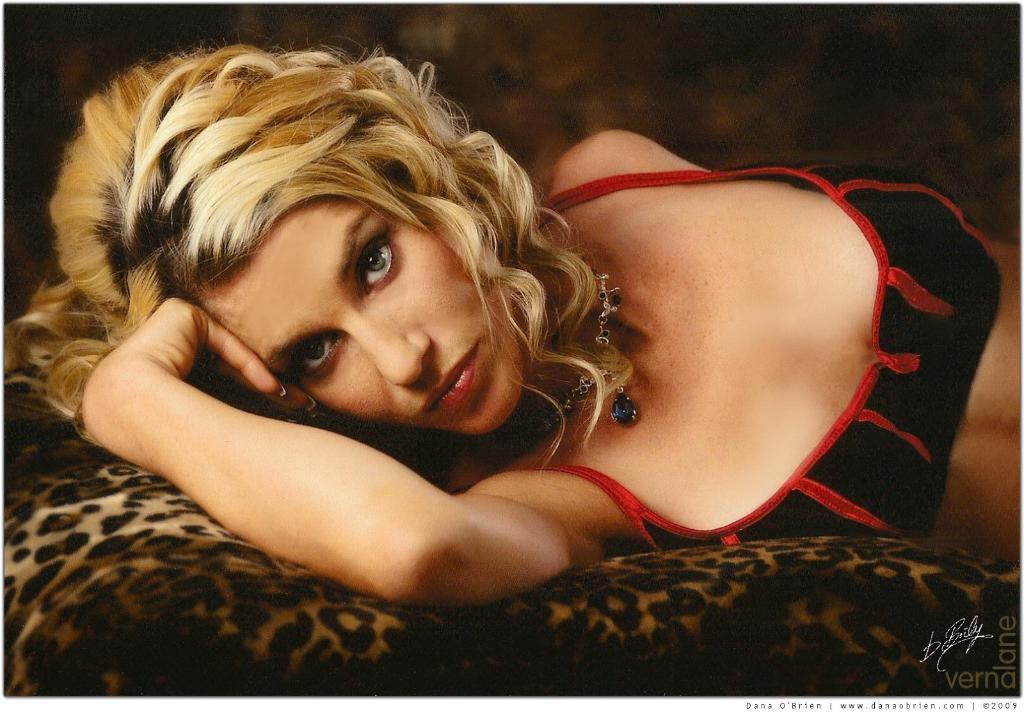How would you summarize this image in a sentence or two? In this picture we can see women slept on a sofa material and she wore chain some jewelry and looking at something. 